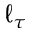Convert formula to latex. <formula><loc_0><loc_0><loc_500><loc_500>\ell _ { \tau }</formula> 